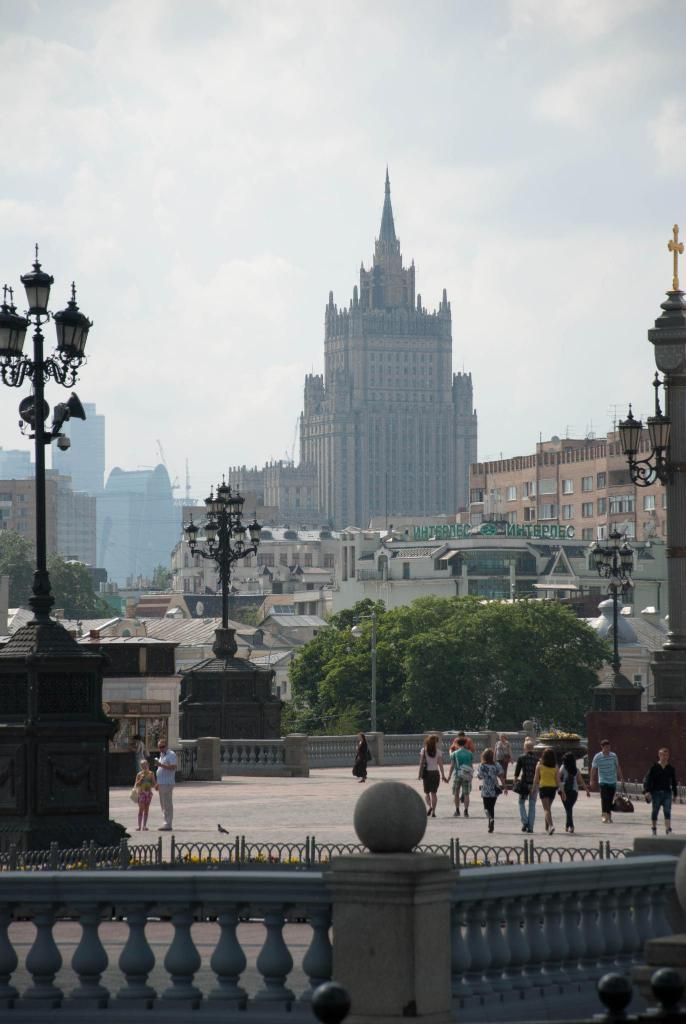What are the people in the image doing? The people in the image are walking. On what surface are the people walking? The people are walking on the floor. What type of lighting can be seen in the image? There are street lights in the image. What type of structures are visible in the image? There are buildings in the image. What type of vegetation is present in the image? There are trees in the image. What is visible at the top of the image? The sky is visible at the top of the image. What type of tin can be seen on the ground in the image? There is no tin present on the ground in the image. What type of earth is visible in the image? The image does not show any specific type of earth; it depicts a scene with people, buildings, trees, and the sky. 